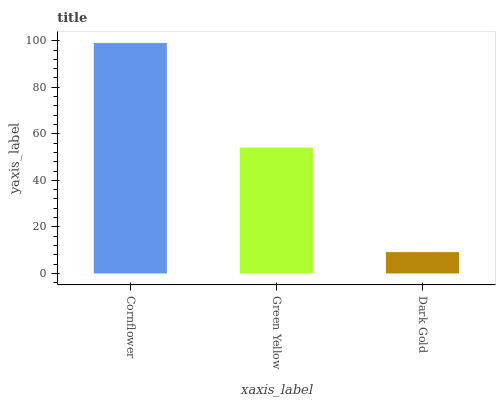Is Dark Gold the minimum?
Answer yes or no. Yes. Is Cornflower the maximum?
Answer yes or no. Yes. Is Green Yellow the minimum?
Answer yes or no. No. Is Green Yellow the maximum?
Answer yes or no. No. Is Cornflower greater than Green Yellow?
Answer yes or no. Yes. Is Green Yellow less than Cornflower?
Answer yes or no. Yes. Is Green Yellow greater than Cornflower?
Answer yes or no. No. Is Cornflower less than Green Yellow?
Answer yes or no. No. Is Green Yellow the high median?
Answer yes or no. Yes. Is Green Yellow the low median?
Answer yes or no. Yes. Is Cornflower the high median?
Answer yes or no. No. Is Cornflower the low median?
Answer yes or no. No. 